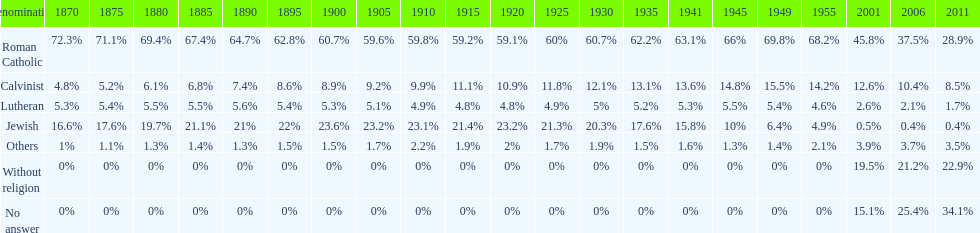Which denomination has the highest margin? Roman Catholic. 